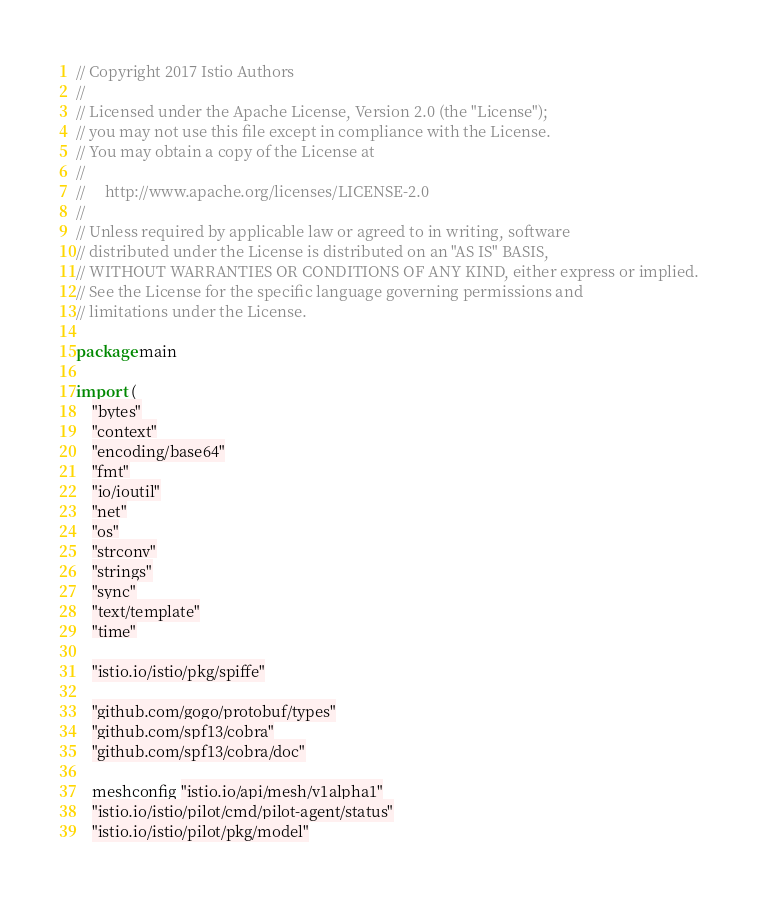Convert code to text. <code><loc_0><loc_0><loc_500><loc_500><_Go_>// Copyright 2017 Istio Authors
//
// Licensed under the Apache License, Version 2.0 (the "License");
// you may not use this file except in compliance with the License.
// You may obtain a copy of the License at
//
//     http://www.apache.org/licenses/LICENSE-2.0
//
// Unless required by applicable law or agreed to in writing, software
// distributed under the License is distributed on an "AS IS" BASIS,
// WITHOUT WARRANTIES OR CONDITIONS OF ANY KIND, either express or implied.
// See the License for the specific language governing permissions and
// limitations under the License.

package main

import (
	"bytes"
	"context"
	"encoding/base64"
	"fmt"
	"io/ioutil"
	"net"
	"os"
	"strconv"
	"strings"
	"sync"
	"text/template"
	"time"

	"istio.io/istio/pkg/spiffe"

	"github.com/gogo/protobuf/types"
	"github.com/spf13/cobra"
	"github.com/spf13/cobra/doc"

	meshconfig "istio.io/api/mesh/v1alpha1"
	"istio.io/istio/pilot/cmd/pilot-agent/status"
	"istio.io/istio/pilot/pkg/model"</code> 